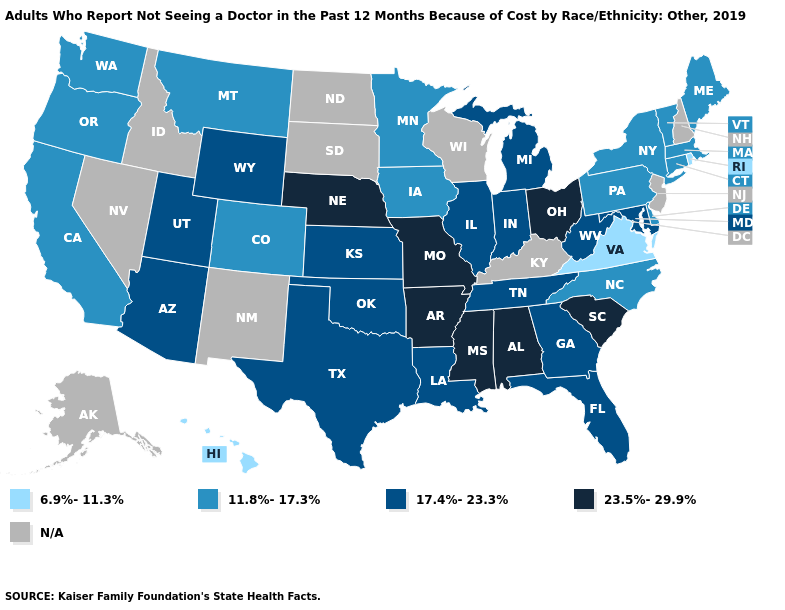Does Hawaii have the lowest value in the West?
Write a very short answer. Yes. Which states have the highest value in the USA?
Short answer required. Alabama, Arkansas, Mississippi, Missouri, Nebraska, Ohio, South Carolina. Name the states that have a value in the range N/A?
Concise answer only. Alaska, Idaho, Kentucky, Nevada, New Hampshire, New Jersey, New Mexico, North Dakota, South Dakota, Wisconsin. Which states have the highest value in the USA?
Quick response, please. Alabama, Arkansas, Mississippi, Missouri, Nebraska, Ohio, South Carolina. What is the highest value in the MidWest ?
Short answer required. 23.5%-29.9%. What is the value of Hawaii?
Give a very brief answer. 6.9%-11.3%. Name the states that have a value in the range 6.9%-11.3%?
Keep it brief. Hawaii, Rhode Island, Virginia. Name the states that have a value in the range 11.8%-17.3%?
Be succinct. California, Colorado, Connecticut, Delaware, Iowa, Maine, Massachusetts, Minnesota, Montana, New York, North Carolina, Oregon, Pennsylvania, Vermont, Washington. Name the states that have a value in the range 6.9%-11.3%?
Answer briefly. Hawaii, Rhode Island, Virginia. What is the value of Massachusetts?
Write a very short answer. 11.8%-17.3%. Does South Carolina have the lowest value in the USA?
Give a very brief answer. No. Does the first symbol in the legend represent the smallest category?
Give a very brief answer. Yes. Among the states that border Missouri , does Arkansas have the lowest value?
Quick response, please. No. 